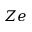<formula> <loc_0><loc_0><loc_500><loc_500>Z e</formula> 